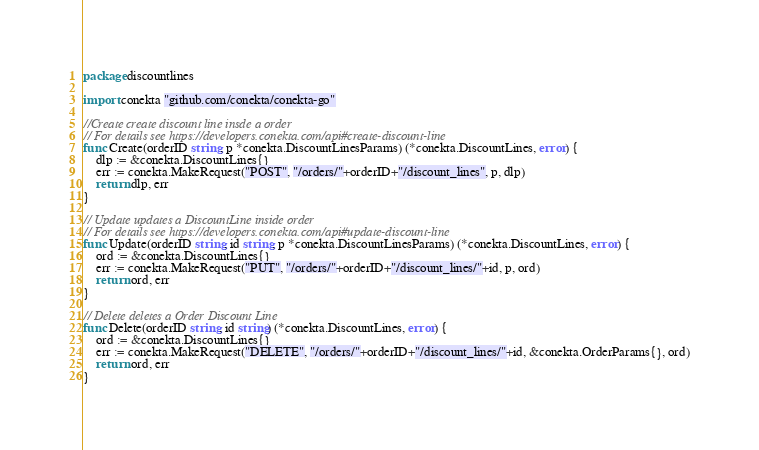<code> <loc_0><loc_0><loc_500><loc_500><_Go_>package discountlines

import conekta "github.com/conekta/conekta-go"

//Create create discount line insde a order
// For details see https://developers.conekta.com/api#create-discount-line
func Create(orderID string, p *conekta.DiscountLinesParams) (*conekta.DiscountLines, error) {
	dlp := &conekta.DiscountLines{}
	err := conekta.MakeRequest("POST", "/orders/"+orderID+"/discount_lines", p, dlp)
	return dlp, err
}

// Update updates a DiscountLine inside order
// For details see https://developers.conekta.com/api#update-discount-line
func Update(orderID string, id string, p *conekta.DiscountLinesParams) (*conekta.DiscountLines, error) {
	ord := &conekta.DiscountLines{}
	err := conekta.MakeRequest("PUT", "/orders/"+orderID+"/discount_lines/"+id, p, ord)
	return ord, err
}

// Delete deletes a Order Discount Line
func Delete(orderID string, id string) (*conekta.DiscountLines, error) {
	ord := &conekta.DiscountLines{}
	err := conekta.MakeRequest("DELETE", "/orders/"+orderID+"/discount_lines/"+id, &conekta.OrderParams{}, ord)
	return ord, err
}
</code> 